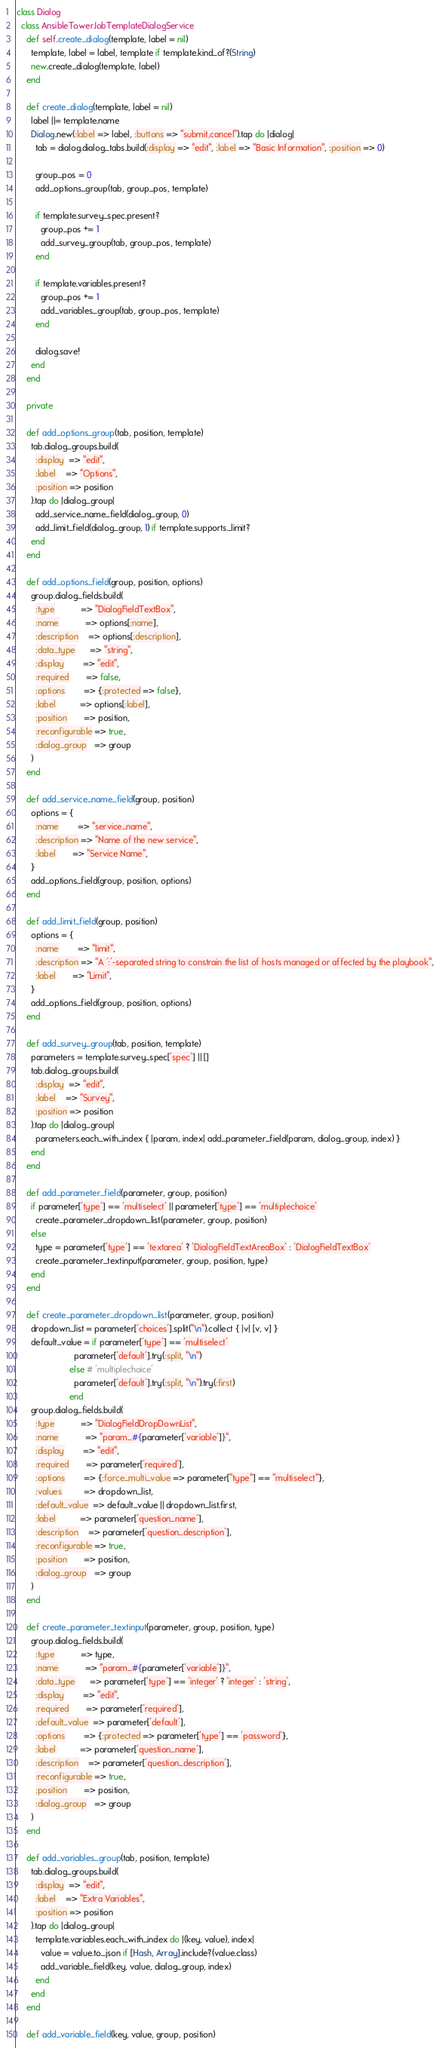Convert code to text. <code><loc_0><loc_0><loc_500><loc_500><_Ruby_>class Dialog
  class AnsibleTowerJobTemplateDialogService
    def self.create_dialog(template, label = nil)
      template, label = label, template if template.kind_of?(String)
      new.create_dialog(template, label)
    end

    def create_dialog(template, label = nil)
      label ||= template.name
      Dialog.new(:label => label, :buttons => "submit,cancel").tap do |dialog|
        tab = dialog.dialog_tabs.build(:display => "edit", :label => "Basic Information", :position => 0)

        group_pos = 0
        add_options_group(tab, group_pos, template)

        if template.survey_spec.present?
          group_pos += 1
          add_survey_group(tab, group_pos, template)
        end

        if template.variables.present?
          group_pos += 1
          add_variables_group(tab, group_pos, template)
        end

        dialog.save!
      end
    end

    private

    def add_options_group(tab, position, template)
      tab.dialog_groups.build(
        :display  => "edit",
        :label    => "Options",
        :position => position
      ).tap do |dialog_group|
        add_service_name_field(dialog_group, 0)
        add_limit_field(dialog_group, 1) if template.supports_limit?
      end
    end

    def add_options_field(group, position, options)
      group.dialog_fields.build(
        :type           => "DialogFieldTextBox",
        :name           => options[:name],
        :description    => options[:description],
        :data_type      => "string",
        :display        => "edit",
        :required       => false,
        :options        => {:protected => false},
        :label          => options[:label],
        :position       => position,
        :reconfigurable => true,
        :dialog_group   => group
      )
    end

    def add_service_name_field(group, position)
      options = {
        :name        => "service_name",
        :description => "Name of the new service",
        :label       => "Service Name",
      }
      add_options_field(group, position, options)
    end

    def add_limit_field(group, position)
      options = {
        :name        => "limit",
        :description => "A ':'-separated string to constrain the list of hosts managed or affected by the playbook",
        :label       => "Limit",
      }
      add_options_field(group, position, options)
    end

    def add_survey_group(tab, position, template)
      parameters = template.survey_spec['spec'] || []
      tab.dialog_groups.build(
        :display  => "edit",
        :label    => "Survey",
        :position => position
      ).tap do |dialog_group|
        parameters.each_with_index { |param, index| add_parameter_field(param, dialog_group, index) }
      end
    end

    def add_parameter_field(parameter, group, position)
      if parameter['type'] == 'multiselect' || parameter['type'] == 'multiplechoice'
        create_parameter_dropdown_list(parameter, group, position)
      else
        type = parameter['type'] == 'textarea' ? 'DialogFieldTextAreaBox' : 'DialogFieldTextBox'
        create_parameter_textinput(parameter, group, position, type)
      end
    end

    def create_parameter_dropdown_list(parameter, group, position)
      dropdown_list = parameter['choices'].split("\n").collect { |v| [v, v] }
      default_value = if parameter['type'] == 'multiselect'
                        parameter['default'].try(:split, "\n")
                      else # 'multiplechoice'
                        parameter['default'].try(:split, "\n").try(:first)
                      end
      group.dialog_fields.build(
        :type           => "DialogFieldDropDownList",
        :name           => "param_#{parameter['variable']}",
        :display        => "edit",
        :required       => parameter['required'],
        :options        => {:force_multi_value => parameter["type"] == "multiselect"},
        :values         => dropdown_list,
        :default_value  => default_value || dropdown_list.first,
        :label          => parameter['question_name'],
        :description    => parameter['question_description'],
        :reconfigurable => true,
        :position       => position,
        :dialog_group   => group
      )
    end

    def create_parameter_textinput(parameter, group, position, type)
      group.dialog_fields.build(
        :type           => type,
        :name           => "param_#{parameter['variable']}",
        :data_type      => parameter['type'] == 'integer' ? 'integer' : 'string',
        :display        => "edit",
        :required       => parameter['required'],
        :default_value  => parameter['default'],
        :options        => {:protected => parameter['type'] == 'password'},
        :label          => parameter['question_name'],
        :description    => parameter['question_description'],
        :reconfigurable => true,
        :position       => position,
        :dialog_group   => group
      )
    end

    def add_variables_group(tab, position, template)
      tab.dialog_groups.build(
        :display  => "edit",
        :label    => "Extra Variables",
        :position => position
      ).tap do |dialog_group|
        template.variables.each_with_index do |(key, value), index|
          value = value.to_json if [Hash, Array].include?(value.class)
          add_variable_field(key, value, dialog_group, index)
        end
      end
    end

    def add_variable_field(key, value, group, position)</code> 